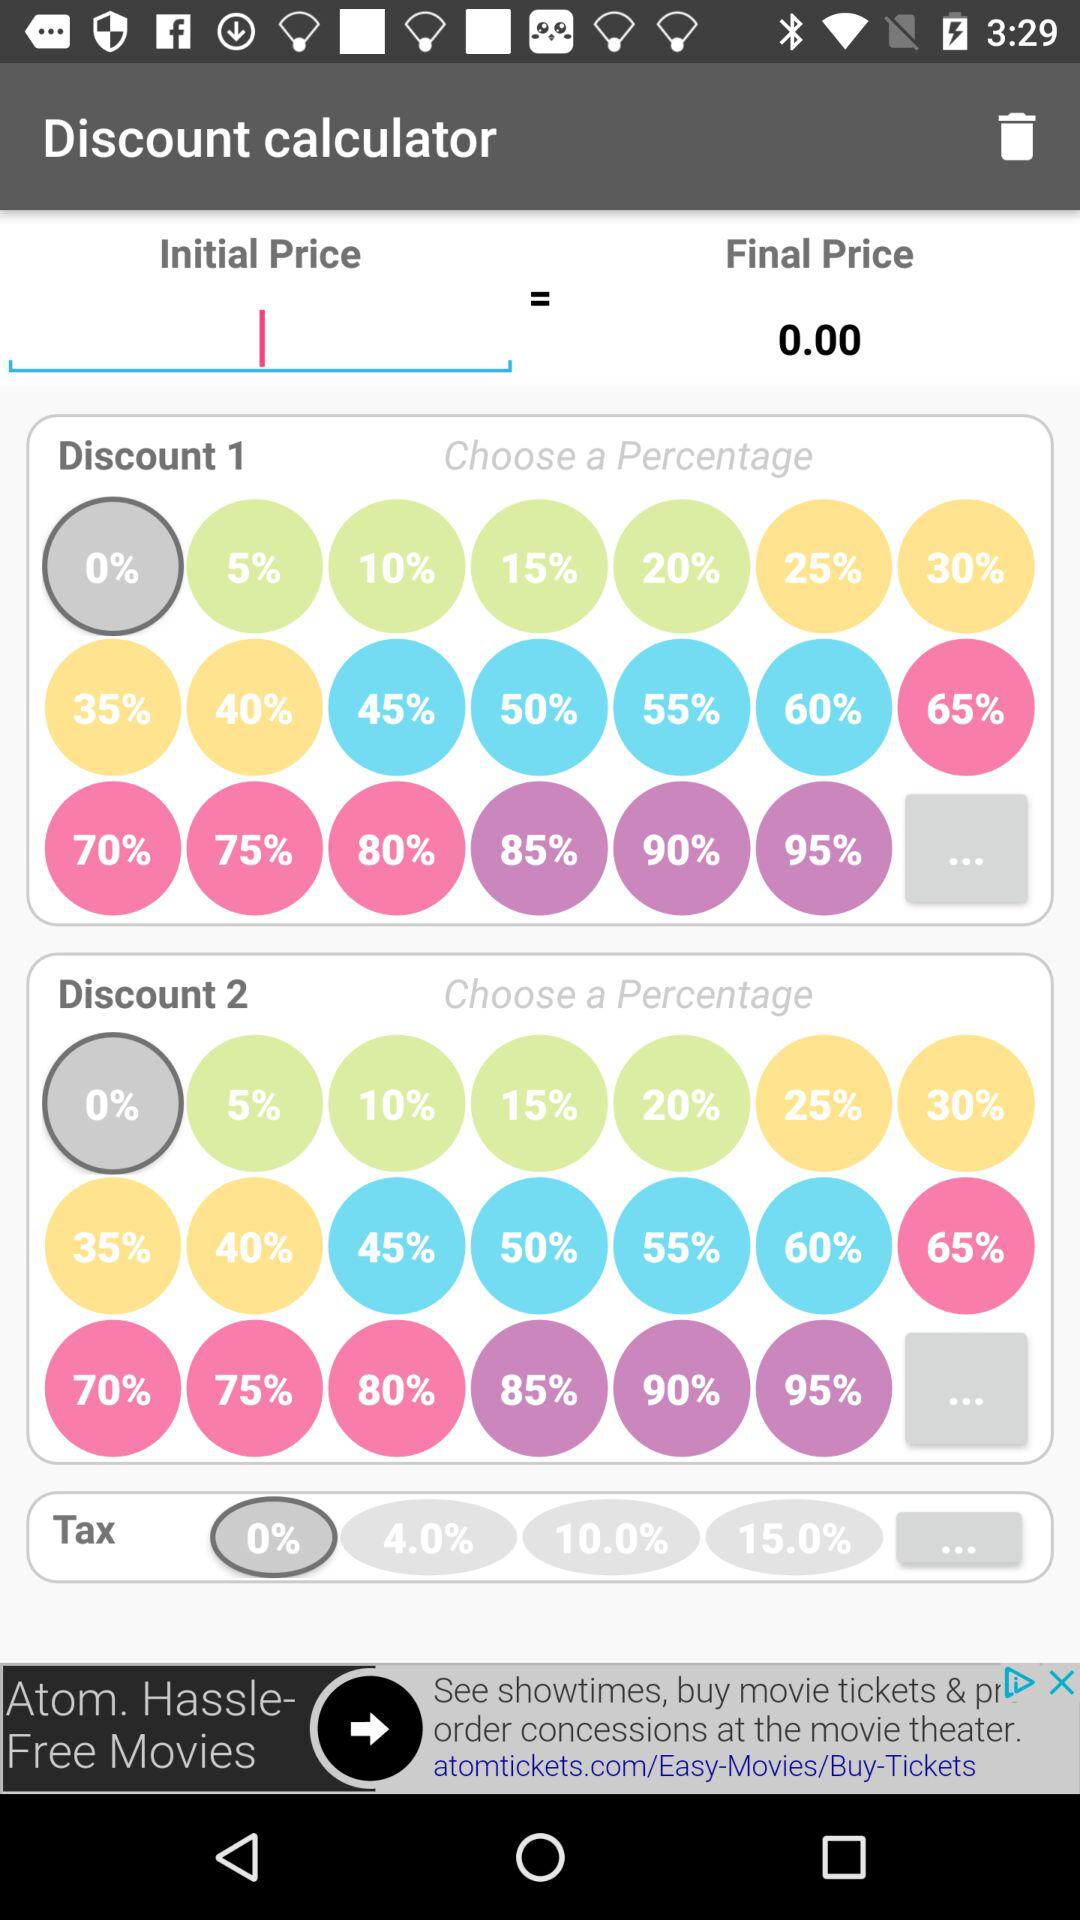Upto What Percentage "Discount 1" list can Avail discount?
When the provided information is insufficient, respond with <no answer>. <no answer> 